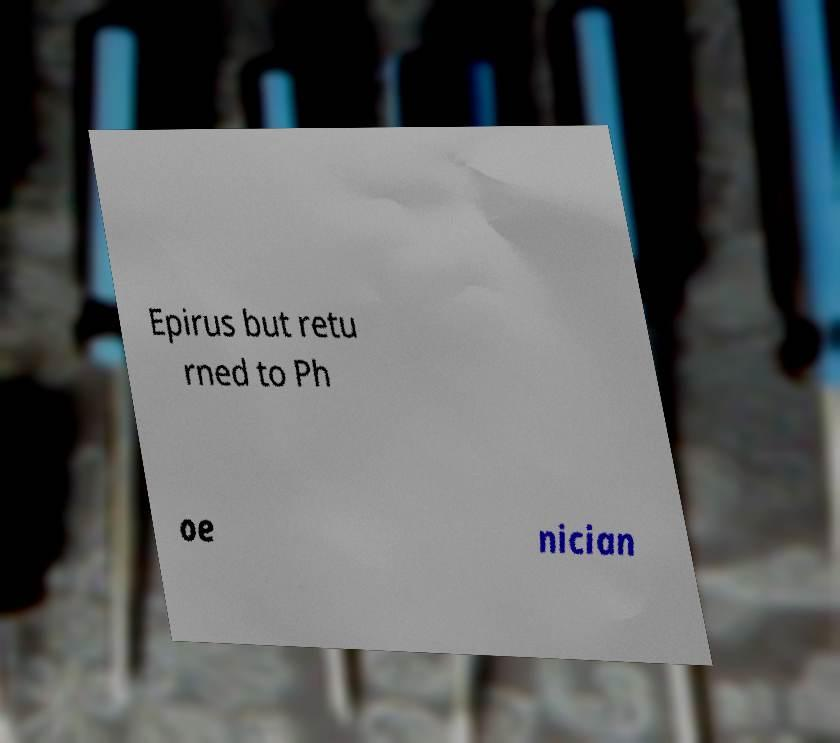For documentation purposes, I need the text within this image transcribed. Could you provide that? Epirus but retu rned to Ph oe nician 